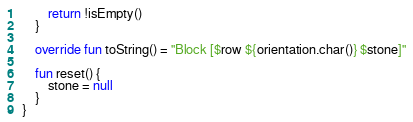<code> <loc_0><loc_0><loc_500><loc_500><_Kotlin_>        return !isEmpty()
    }

    override fun toString() = "Block [$row ${orientation.char()} $stone]"

    fun reset() {
        stone = null
    }
}</code> 